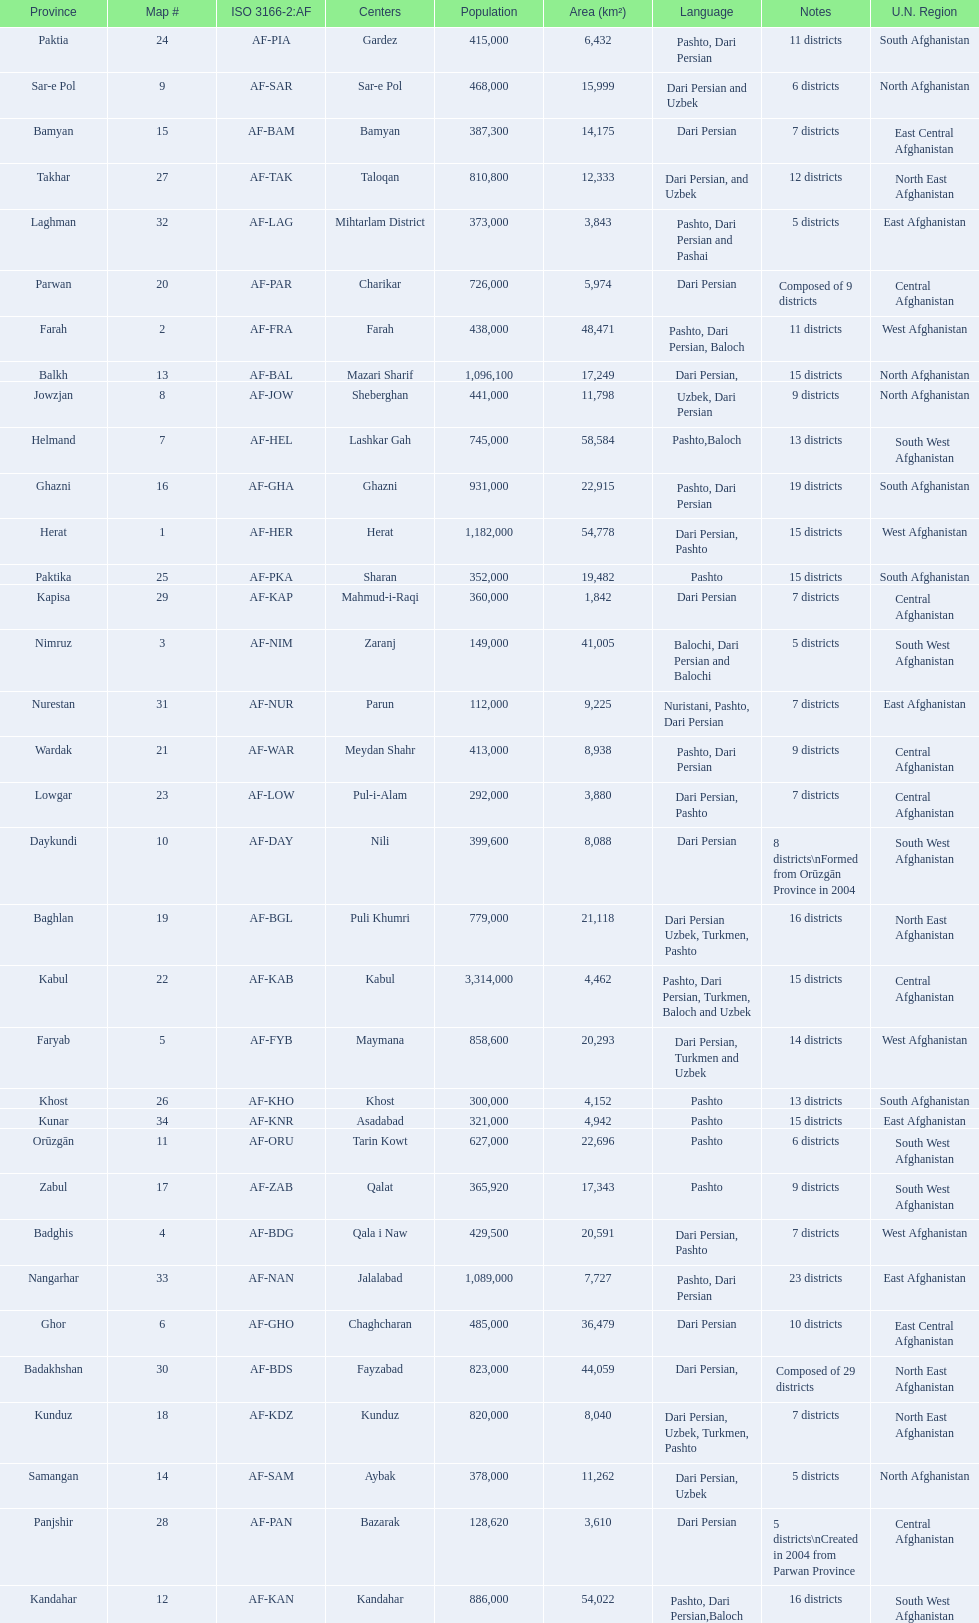How many provinces have pashto as one of their languages 20. 